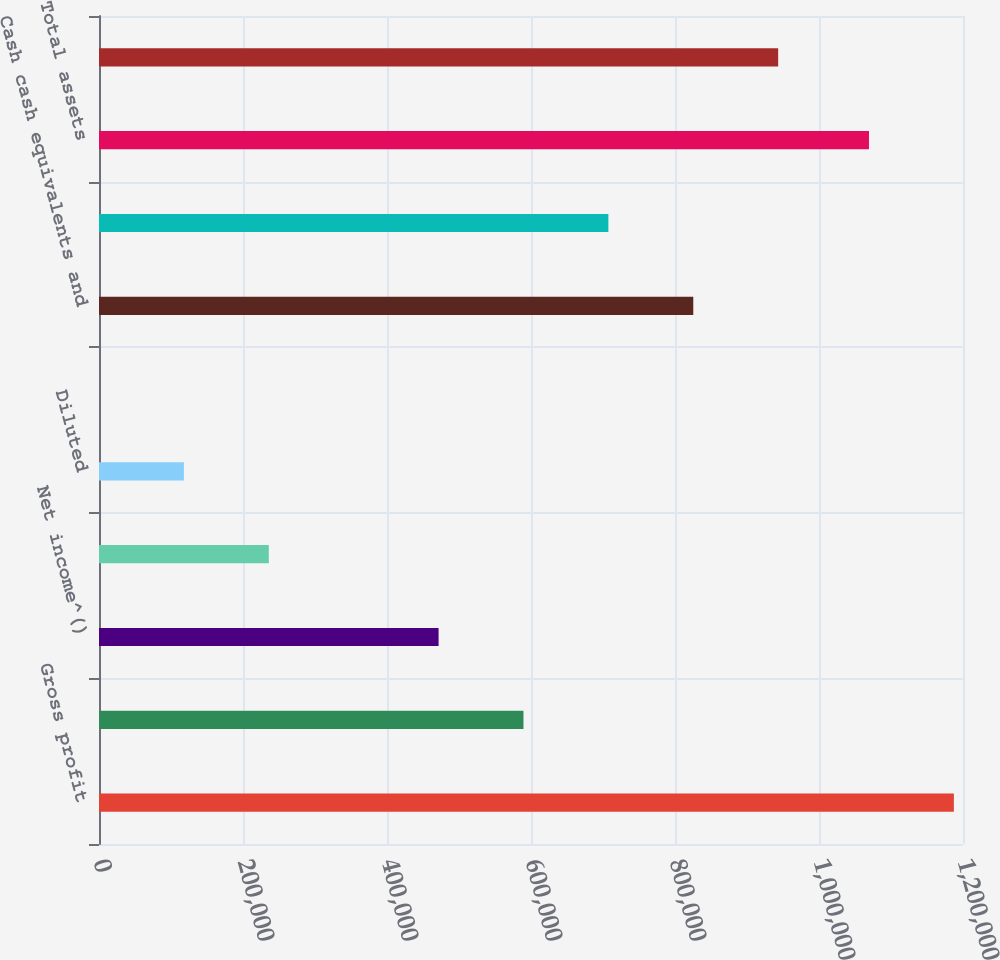Convert chart. <chart><loc_0><loc_0><loc_500><loc_500><bar_chart><fcel>Gross profit<fcel>Income before income taxes<fcel>Net income^()<fcel>Basic<fcel>Diluted<fcel>Cash dividends declared per<fcel>Cash cash equivalents and<fcel>Working capital<fcel>Total assets<fcel>Stockholders' equity<nl><fcel>1.18733e+06<fcel>589562<fcel>471649<fcel>235825<fcel>117912<fcel>0.05<fcel>825386<fcel>707474<fcel>1.06942e+06<fcel>943298<nl></chart> 